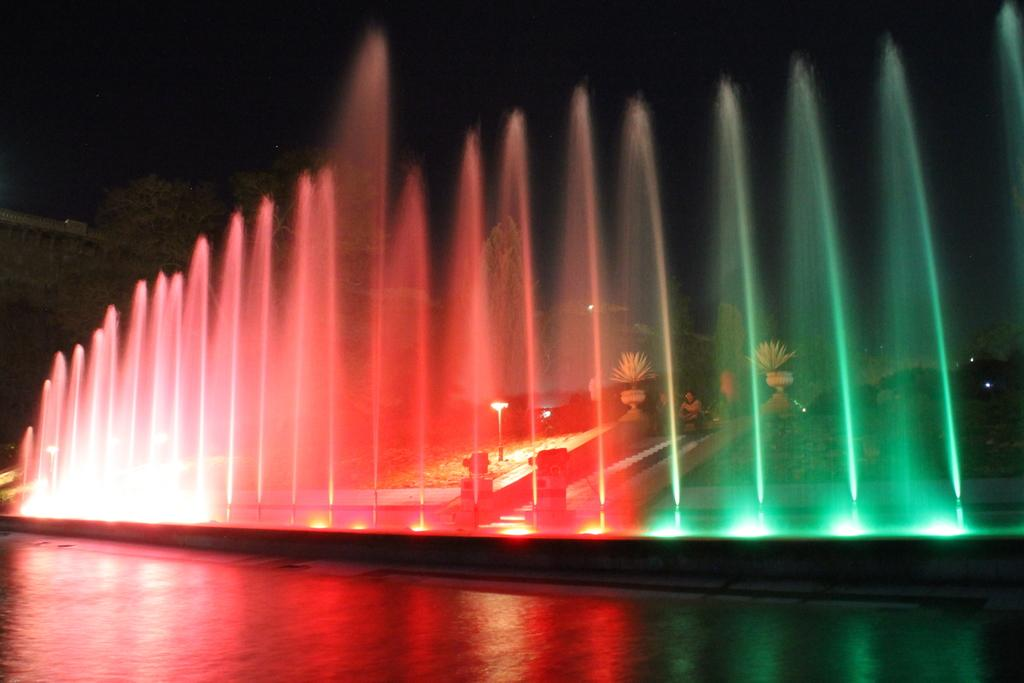What is the main feature in the image? There is a water fountain in the image. What makes the water fountain stand out? The water fountain has colorful lights. What can be seen in the background of the image? There are trees visible in the background of the image. What verse is being recited by the frog in the image? There is no frog present in the image, and therefore no verse being recited. 